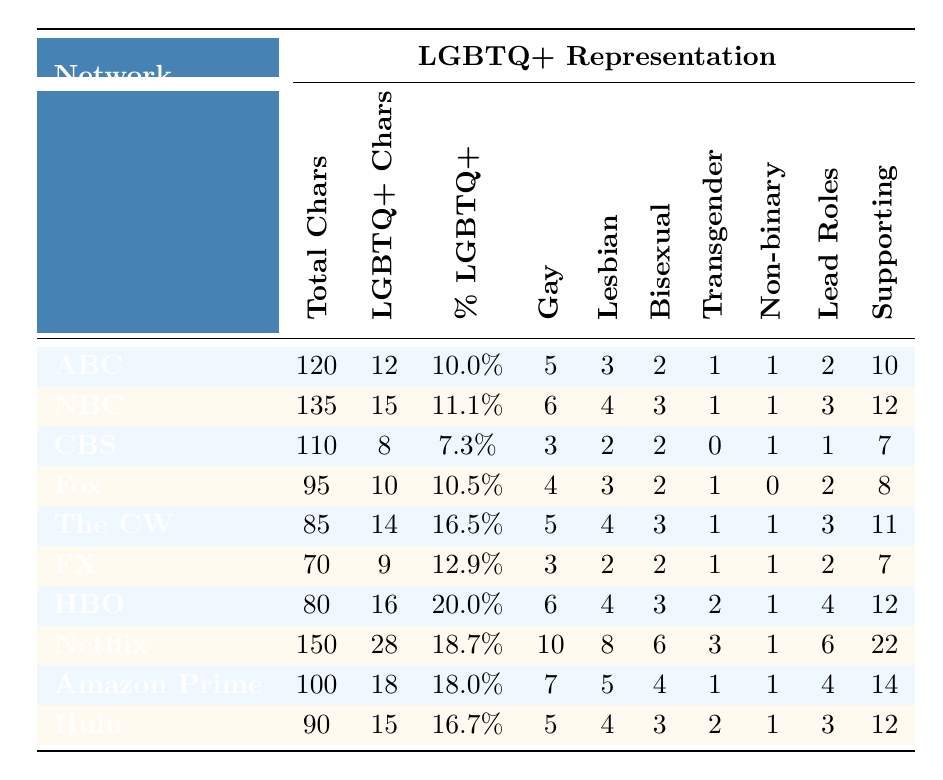What is the total number of LGBTQ+ characters on ABC? The table indicates that the total number of LGBTQ+ characters on ABC is listed in the column under LGBTQ+ Characters, which shows a value of 12.
Answer: 12 Which network has the highest percentage of LGBTQ+ characters? By comparing the Percentage LGBTQ+ column, The CW has the highest percentage at 16.5%.
Answer: The CW How many more LGBTQ+ characters does Netflix have compared to CBS? Netflix has 28 LGBTQ+ characters while CBS has 8. The difference is calculated as 28 - 8 = 20.
Answer: 20 What is the average percentage of LGBTQ+ characters across all networks? To find the average, sum all the percentages: 10.0 + 11.1 + 7.3 + 10.5 + 16.5 + 12.9 + 20.0 + 18.7 + 18.0 + 16.7 = 131.7. Then divide by the number of networks (10): 131.7 / 10 = 13.17.
Answer: 13.17 Does CBS have more LGBTQ+ lead roles than FX? CBS has 1 LGBTQ+ lead role, while FX has 2. Since 1 is less than 2, the answer is no.
Answer: No Which network has the least number of bisexual characters? By examining the Bisexual Characters column, CBS and FX both have 2 bisexual characters, which is the lowest compared to other networks.
Answer: CBS and FX How many more supporting roles does Netflix have compared to NBC? Netflix has 22 supporting roles, while NBC has 12. The difference is calculated as 22 - 12 = 10.
Answer: 10 What proportion of HBO's characters are LGBTQ+? To find the proportion, look at the Percentage LGBTQ+ column for HBO which shows 20.0%, indicating that 20% of HBO characters are LGBTQ+.
Answer: 20.0% Is there a network that has an equal number of gay and lesbian characters? By checking the Gay Characters and Lesbian Characters columns, NBC has 6 gay characters and 4 lesbian characters, while The CW has 5 gay and 4 lesbian, meaning no network has an equal number.
Answer: No Which network has the highest number of LGBTQ+ lead roles? The Lead Roles column shows that Netflix has the highest number with 6 LGBTQ+ lead roles.
Answer: Netflix What is the total number of LGBTQ+ characters across all networks combined? Adding up the values in the LGBTQ+ Characters column yields: 12 + 15 + 8 + 10 + 14 + 9 + 16 + 28 + 18 + 15 =  19 + 27 + 35 + 28 = 138.
Answer: 138 